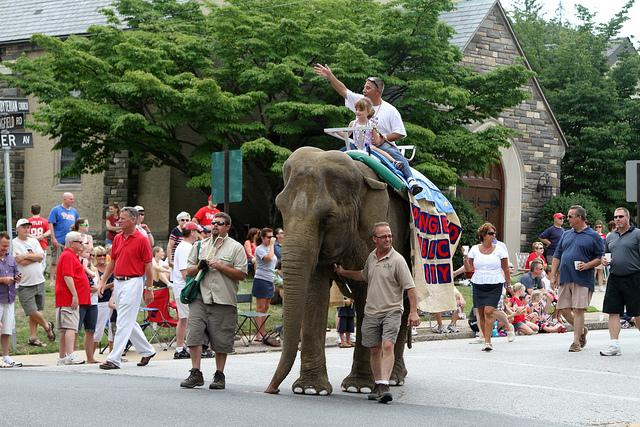What is the long fabric item hanging down the elephant's side?

Choices:
A) blanket
B) curtain
C) banner
D) flag banner 